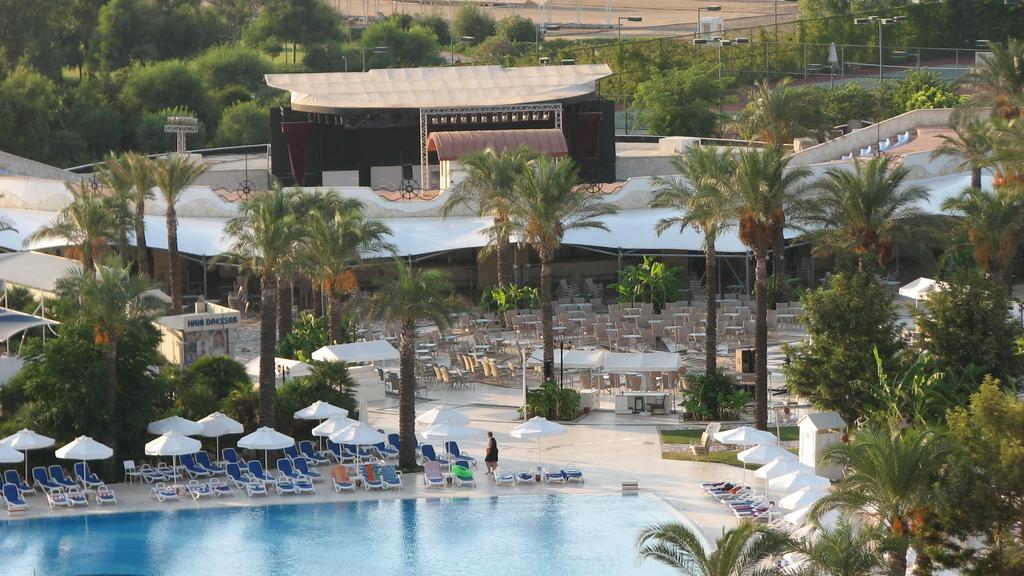Please provide a concise description of this image. In this image I can see trees in green color, in front I can see few umbrellas in white color, chairs in blue color, swimming pool. Background I can see few light poles. 